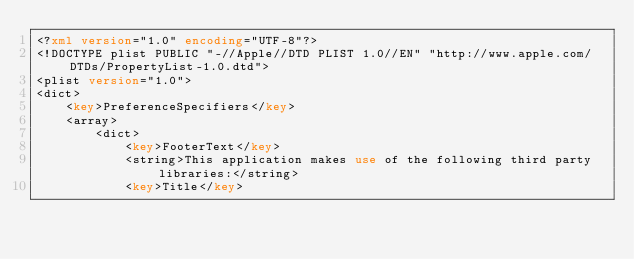<code> <loc_0><loc_0><loc_500><loc_500><_XML_><?xml version="1.0" encoding="UTF-8"?>
<!DOCTYPE plist PUBLIC "-//Apple//DTD PLIST 1.0//EN" "http://www.apple.com/DTDs/PropertyList-1.0.dtd">
<plist version="1.0">
<dict>
	<key>PreferenceSpecifiers</key>
	<array>
		<dict>
			<key>FooterText</key>
			<string>This application makes use of the following third party libraries:</string>
			<key>Title</key></code> 